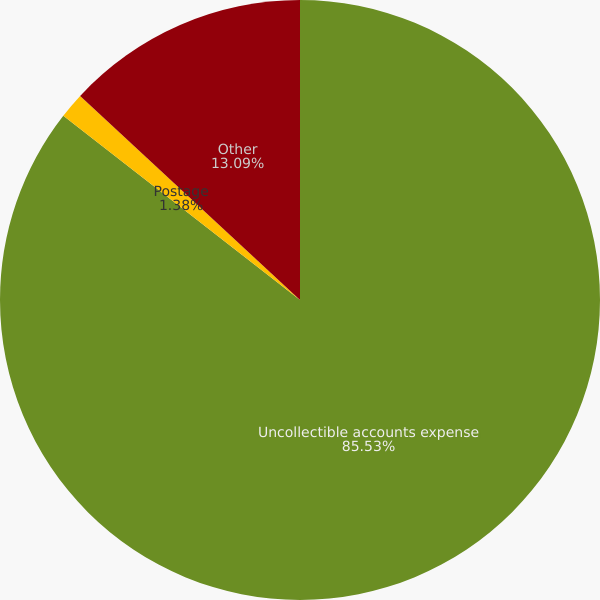Convert chart. <chart><loc_0><loc_0><loc_500><loc_500><pie_chart><fcel>Uncollectible accounts expense<fcel>Postage<fcel>Other<nl><fcel>85.53%<fcel>1.38%<fcel>13.09%<nl></chart> 